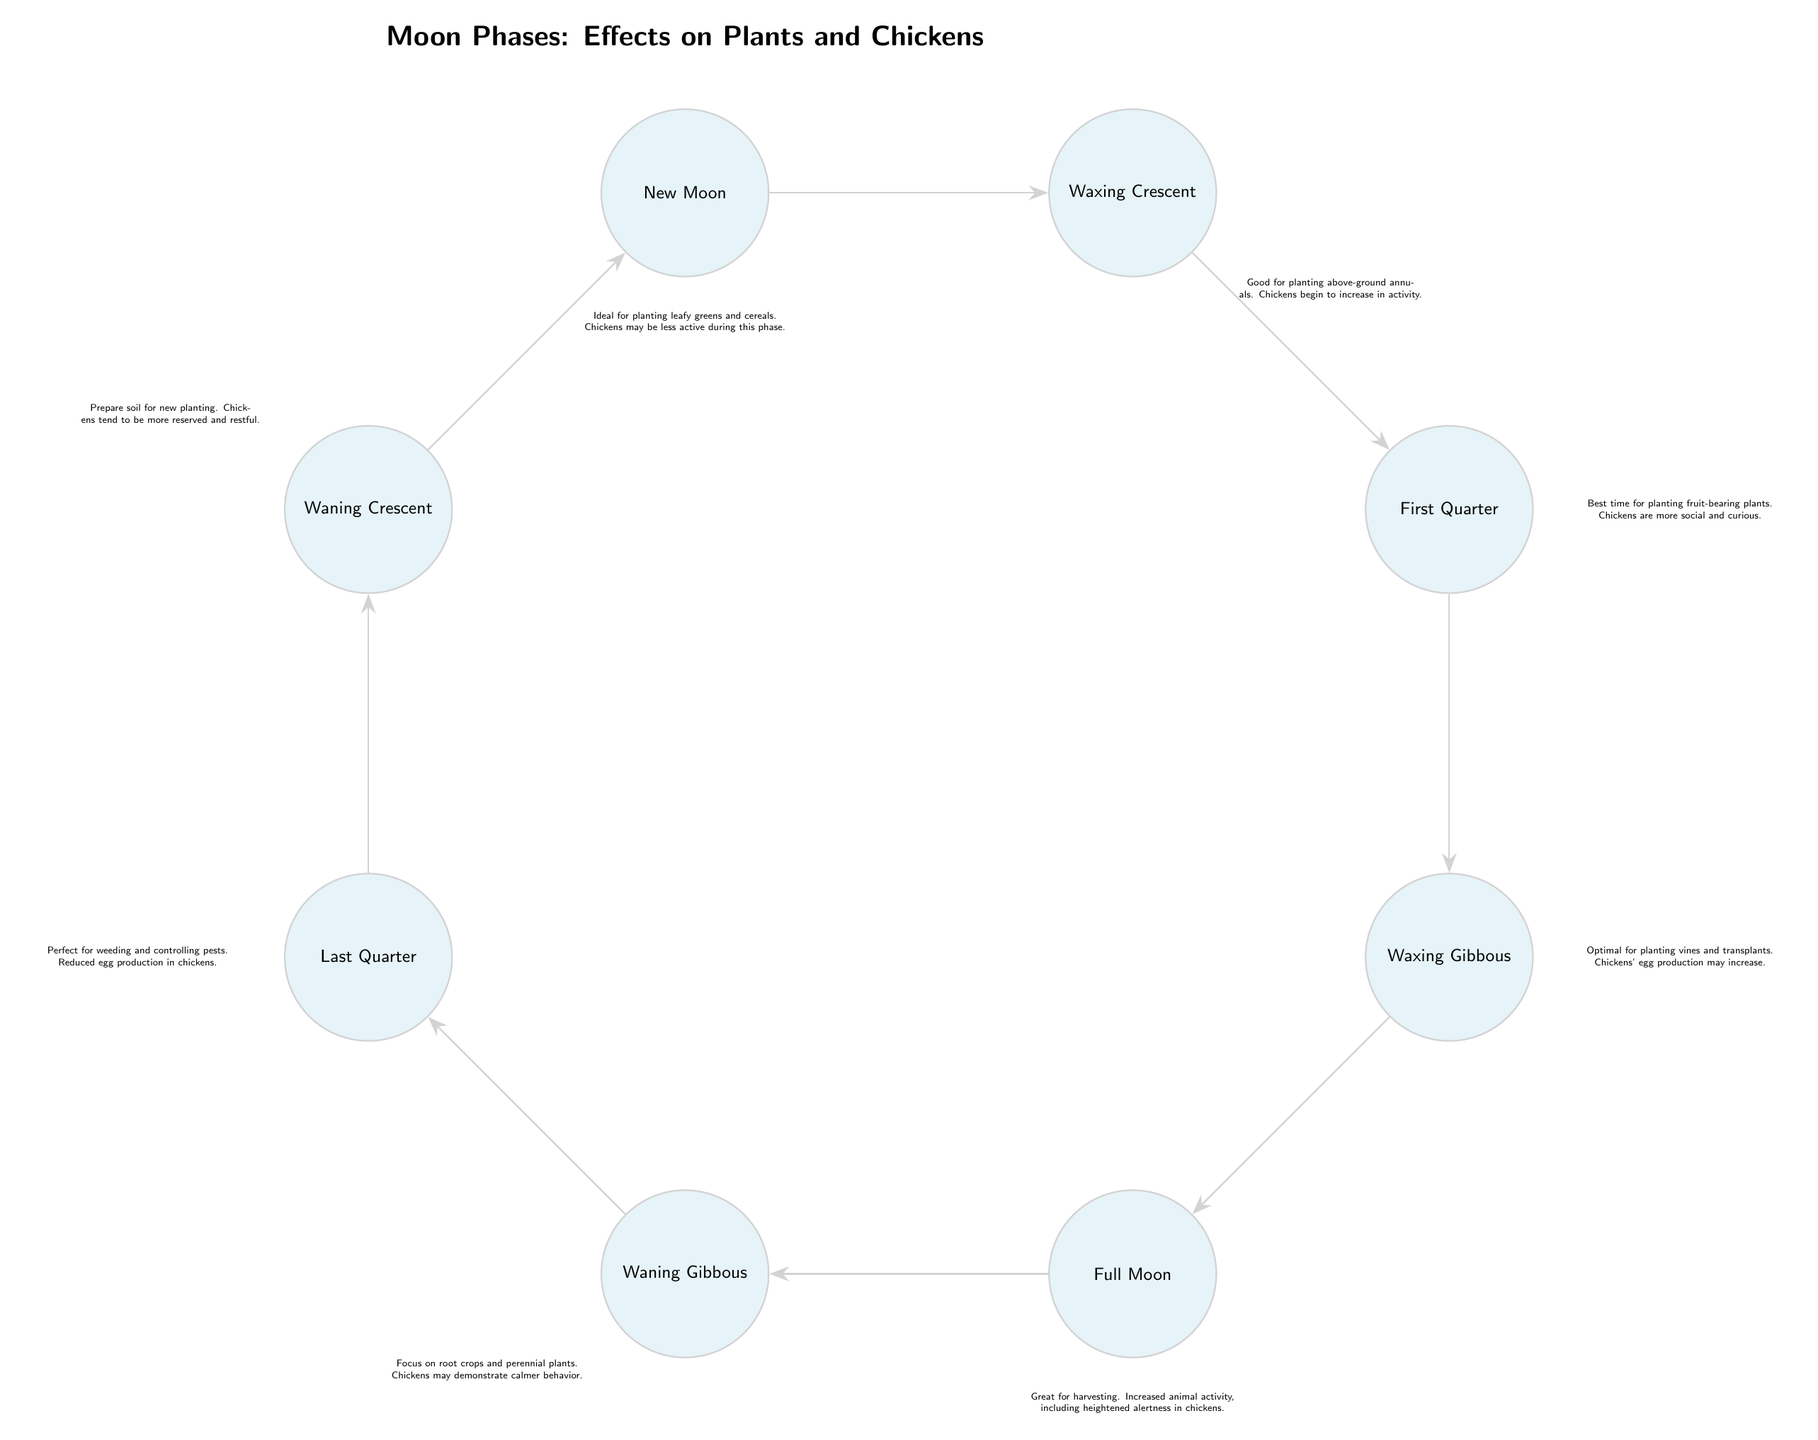What is the phase of the moon that is ideal for planting leafy greens and cereals? The diagram indicates that the phase ideal for planting leafy greens and cereals is the New Moon.
Answer: New Moon What does the waxing gibbous phase indicate for chicken behavior? The description next to the waxing gibbous phase states that chickens' egg production may increase during this time.
Answer: Egg production may increase Which phase is recommended for weeding and controlling pests? The diagram indicates that the Last Quarter phase is perfect for weeding and controlling pests.
Answer: Last Quarter What happens to chicken behavior during the full moon? According to the diagram, during the full moon, there is increased animal activity, including heightened alertness in chickens.
Answer: Heightened alertness How many moon phases are represented in the diagram? The diagram shows a total of eight moon phases arranged in a circular layout. This includes New Moon, Waxing Crescent, First Quarter, Waxing Gibbous, Full Moon, Waning Gibbous, Last Quarter, and Waning Crescent.
Answer: Eight 